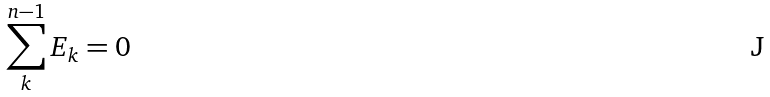<formula> <loc_0><loc_0><loc_500><loc_500>\sum _ { k } ^ { n - 1 } E _ { k } = 0</formula> 